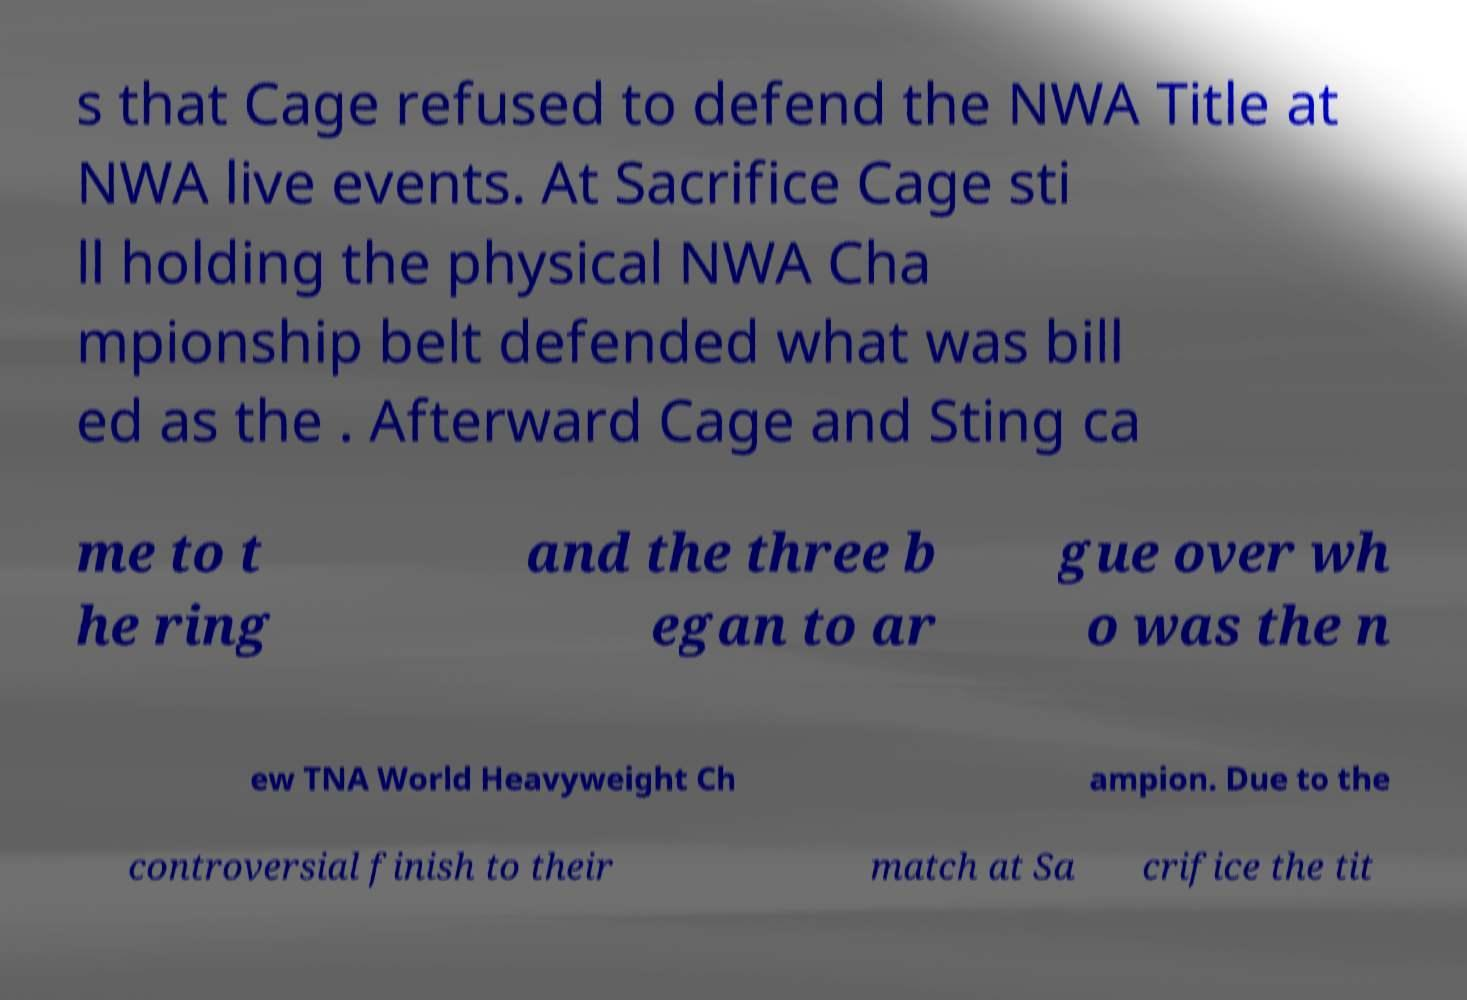Could you assist in decoding the text presented in this image and type it out clearly? s that Cage refused to defend the NWA Title at NWA live events. At Sacrifice Cage sti ll holding the physical NWA Cha mpionship belt defended what was bill ed as the . Afterward Cage and Sting ca me to t he ring and the three b egan to ar gue over wh o was the n ew TNA World Heavyweight Ch ampion. Due to the controversial finish to their match at Sa crifice the tit 